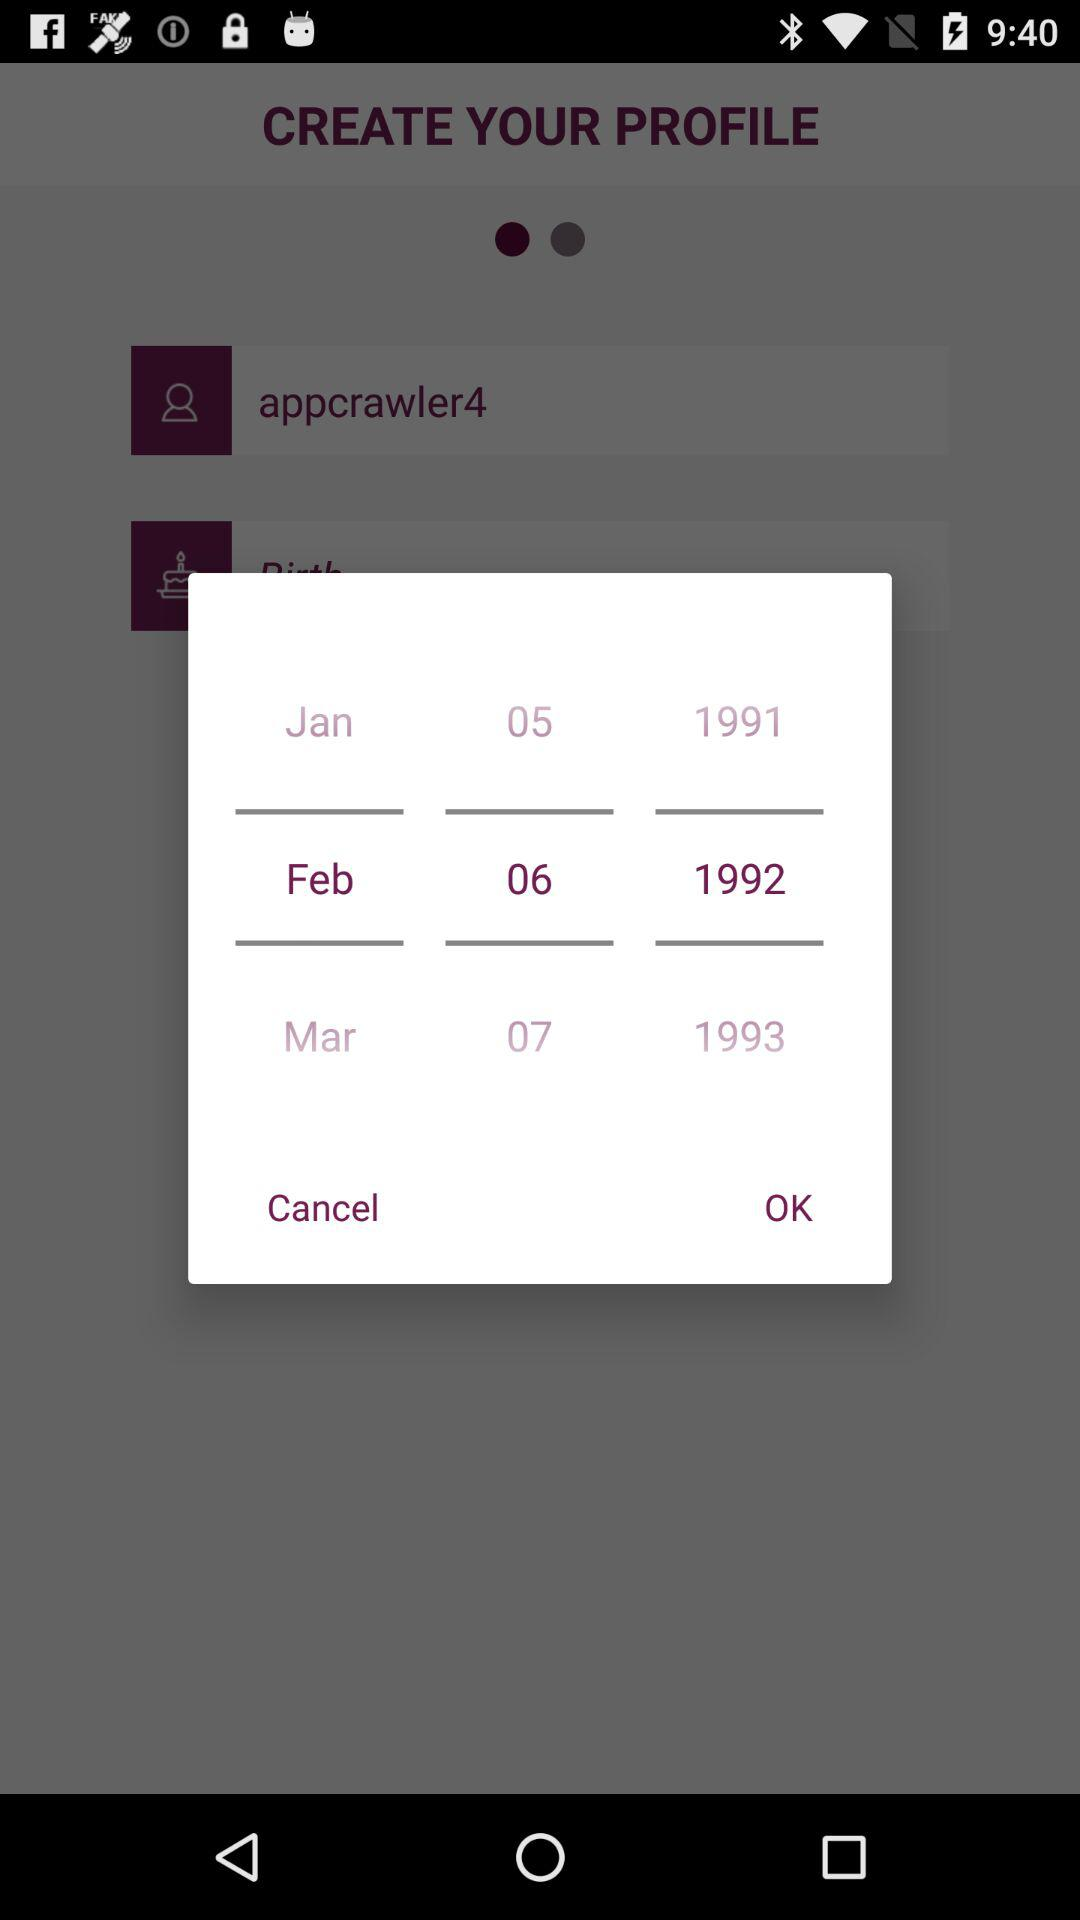What is the date of birth? The date of birth is February 6, 1992. 